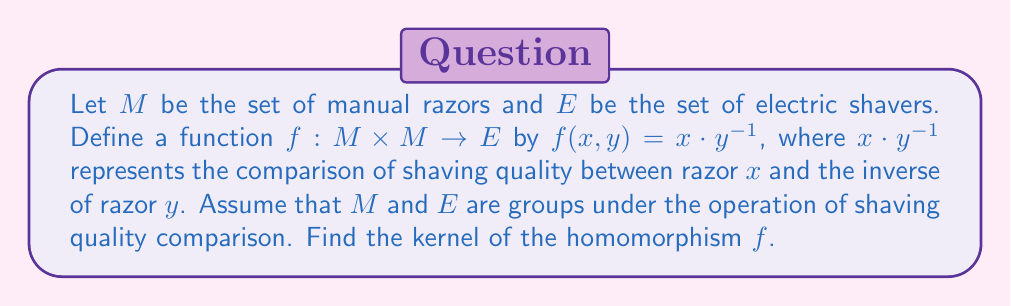Help me with this question. To find the kernel of the homomorphism $f$, we need to determine the set of all elements in the domain that map to the identity element in the codomain. Let's approach this step-by-step:

1) The kernel of $f$ is defined as:
   $\text{ker}(f) = \{(x,y) \in M \times M : f(x,y) = e_E\}$
   where $e_E$ is the identity element in $E$.

2) We know that $f(x,y) = x \cdot y^{-1}$. For this to equal $e_E$, we must have:
   $x \cdot y^{-1} = e_E$

3) Multiplying both sides by $y$ (on the right):
   $(x \cdot y^{-1}) \cdot y = e_E \cdot y$
   $x \cdot (y^{-1} \cdot y) = y$
   $x \cdot e_M = y$
   $x = y$

4) This means that the kernel consists of all pairs $(x,y)$ where $x = y$.

5) We can express this formally as:
   $\text{ker}(f) = \{(x,x) : x \in M\}$

This set is also known as the diagonal of $M \times M$.
Answer: The kernel of the homomorphism $f$ is $\text{ker}(f) = \{(x,x) : x \in M\}$, which is the diagonal of $M \times M$. 